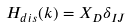<formula> <loc_0><loc_0><loc_500><loc_500>H _ { d i s } ( k ) = X _ { D } \delta _ { I J }</formula> 